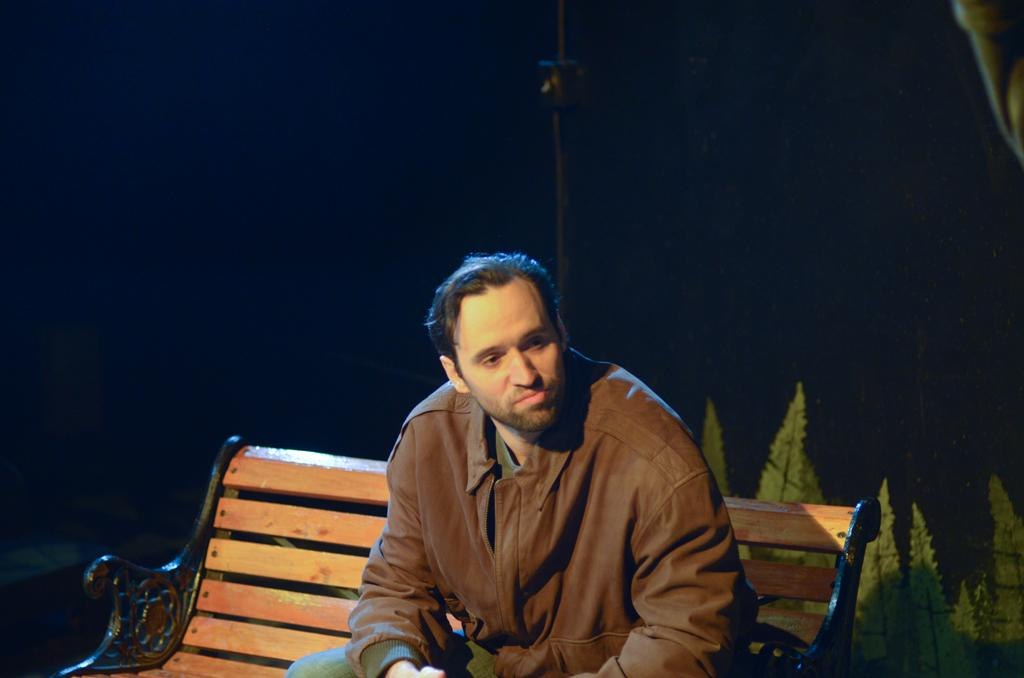What is the man in the image doing? The man is sitting on a bench in the image. What can be seen behind the man? Leaves are visible behind the man. How would you describe the lighting in the image? The background of the image appears to be dark. What type of pancake is the man holding in the image? There is no pancake present in the image; the man is sitting on a bench with leaves visible behind him. 